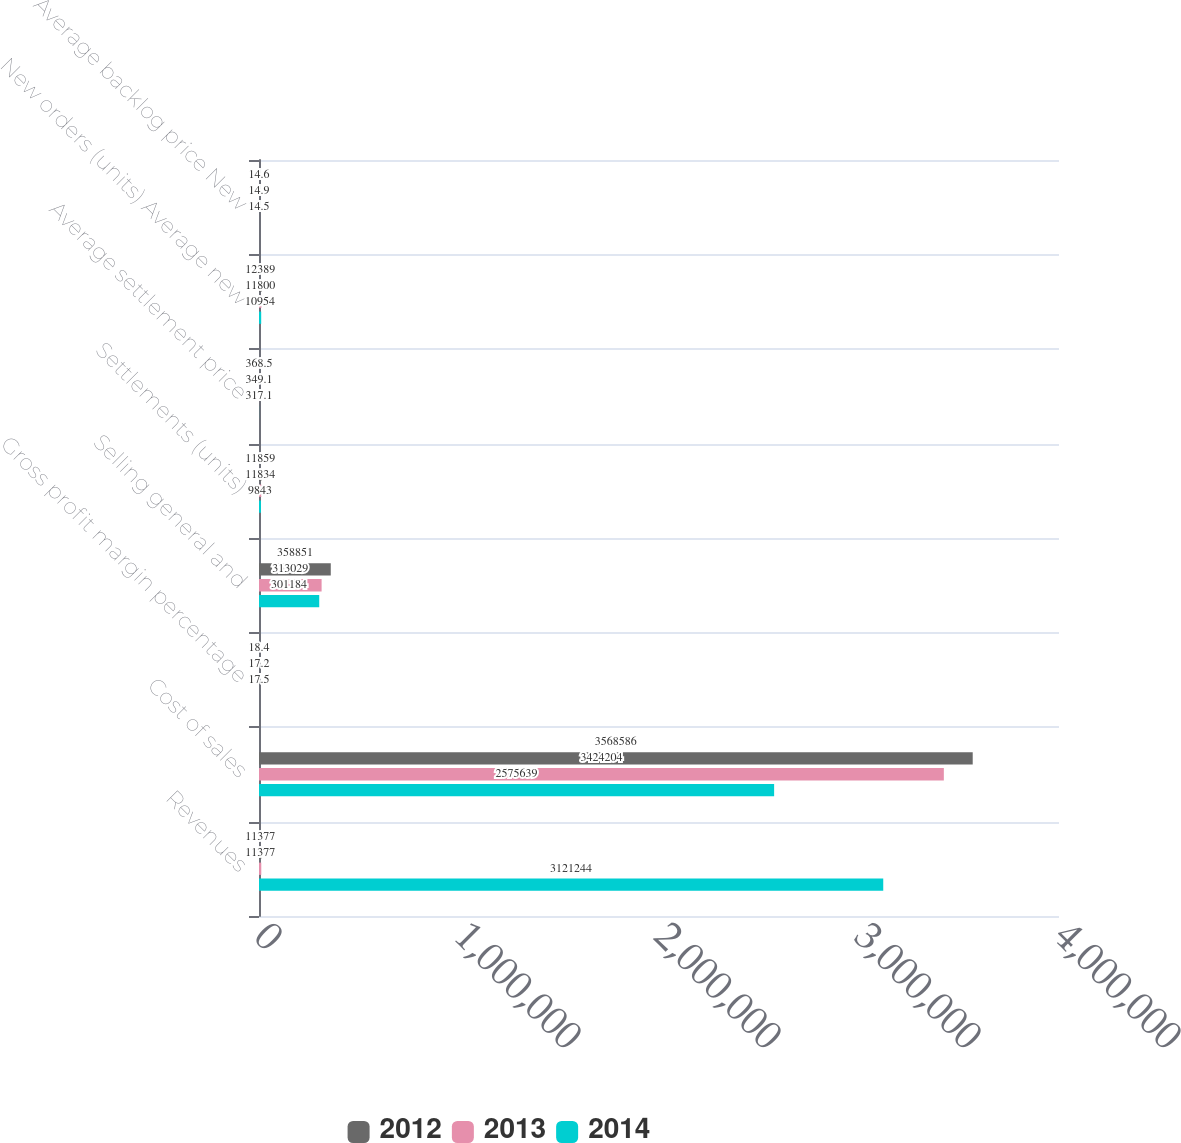<chart> <loc_0><loc_0><loc_500><loc_500><stacked_bar_chart><ecel><fcel>Revenues<fcel>Cost of sales<fcel>Gross profit margin percentage<fcel>Selling general and<fcel>Settlements (units)<fcel>Average settlement price<fcel>New orders (units) Average new<fcel>Average backlog price New<nl><fcel>2012<fcel>11377<fcel>3.56859e+06<fcel>18.4<fcel>358851<fcel>11859<fcel>368.5<fcel>12389<fcel>14.6<nl><fcel>2013<fcel>11377<fcel>3.4242e+06<fcel>17.2<fcel>313029<fcel>11834<fcel>349.1<fcel>11800<fcel>14.9<nl><fcel>2014<fcel>3.12124e+06<fcel>2.57564e+06<fcel>17.5<fcel>301184<fcel>9843<fcel>317.1<fcel>10954<fcel>14.5<nl></chart> 